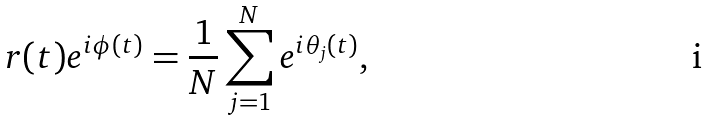<formula> <loc_0><loc_0><loc_500><loc_500>r ( t ) e ^ { i \phi ( t ) } = \frac { 1 } { N } \sum _ { j = 1 } ^ { N } e ^ { i \theta _ { j } ( t ) } ,</formula> 